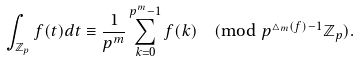Convert formula to latex. <formula><loc_0><loc_0><loc_500><loc_500>\int _ { \mathbb { Z } _ { p } } f ( t ) d t \equiv \frac { 1 } { p ^ { m } } \sum _ { k = 0 } ^ { p ^ { m } - 1 } f ( k ) \pmod { p ^ { \triangle _ { m } ( f ) - 1 } \mathbb { Z } _ { p } } .</formula> 